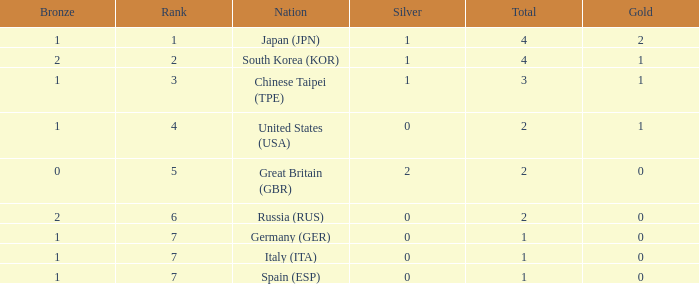What is the smallest number of gold of a country of rank 6, with 2 bronzes? None. 